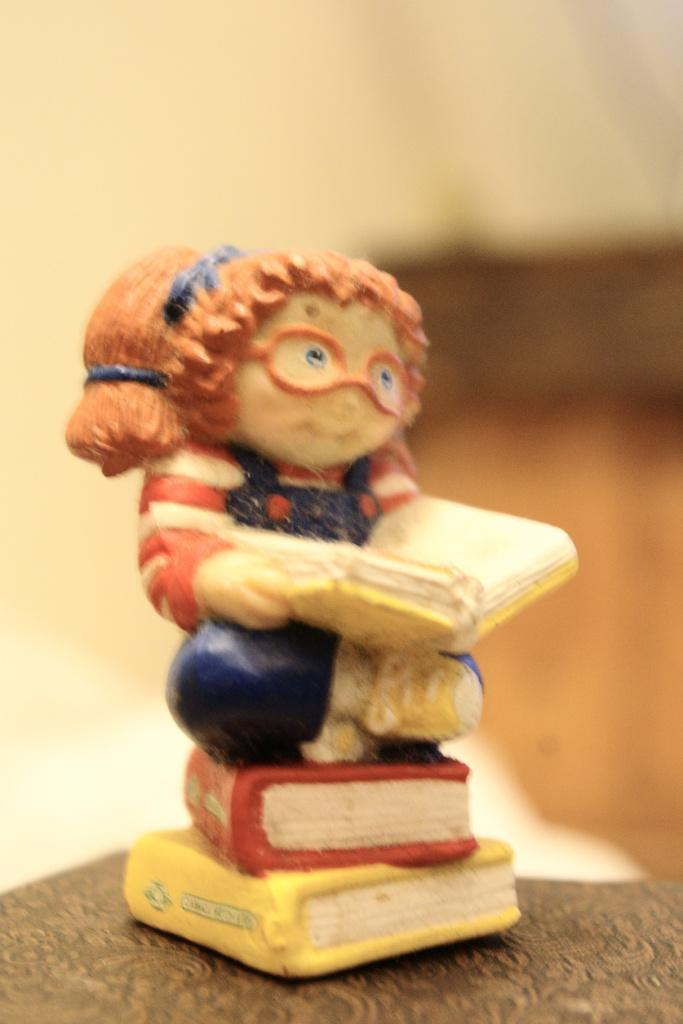What is located on the table in the image? There is a figurine on the table. Can you describe the object on the right side of the image? Unfortunately, the background of the image is blurred, so it is difficult to provide a clear description of the object on the right side. What can be inferred about the focus of the image? The focus of the image appears to be on the figurine on the table, as it is the most clearly visible subject. What type of garden can be seen in the background of the image? There is no garden visible in the image, as the background is blurred. How many pages are visible in the image? There are no pages present in the image. 